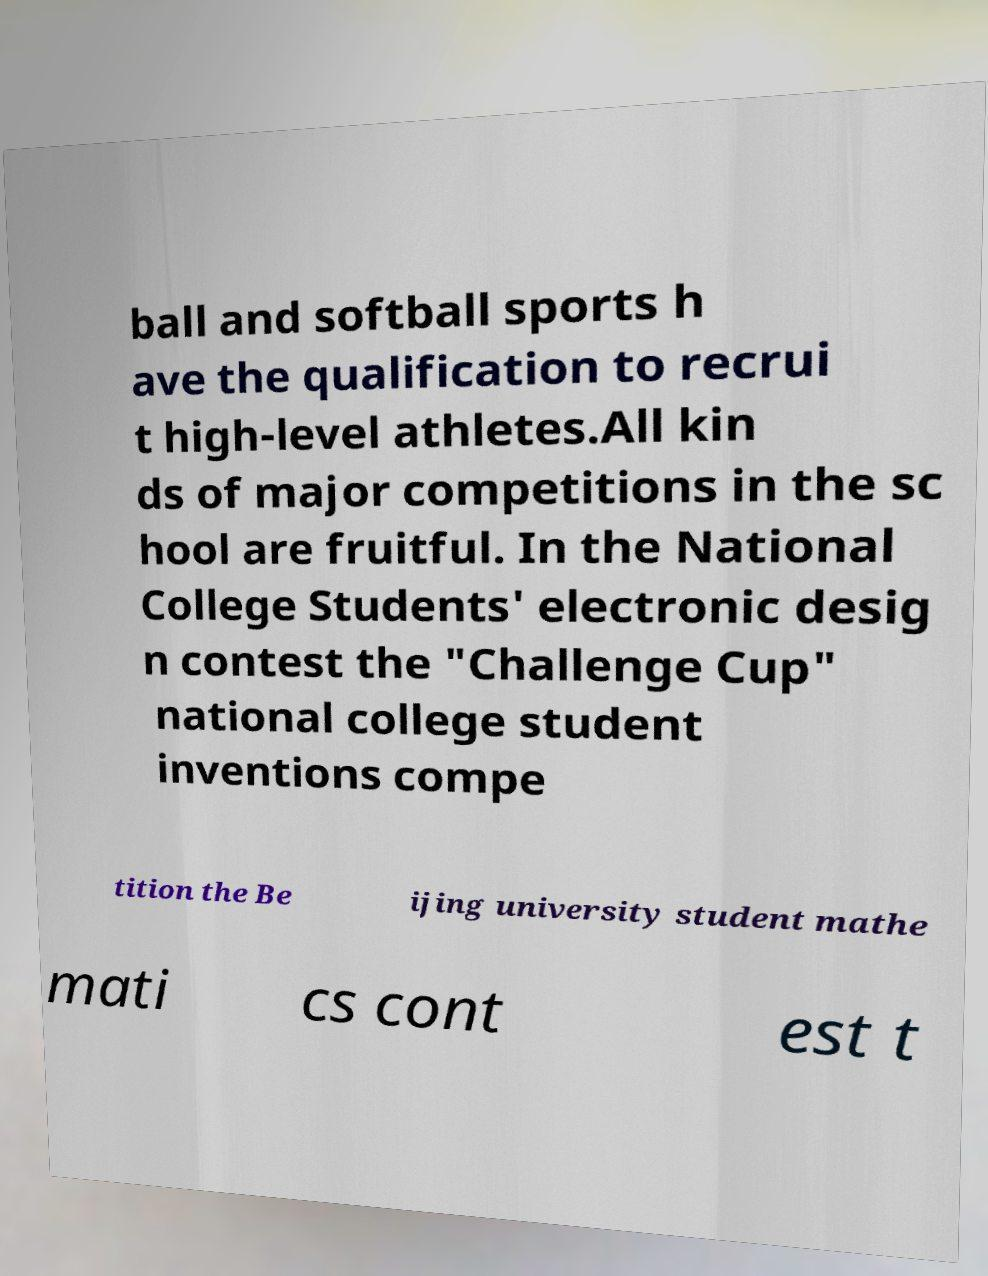Can you accurately transcribe the text from the provided image for me? ball and softball sports h ave the qualification to recrui t high-level athletes.All kin ds of major competitions in the sc hool are fruitful. In the National College Students' electronic desig n contest the "Challenge Cup" national college student inventions compe tition the Be ijing university student mathe mati cs cont est t 